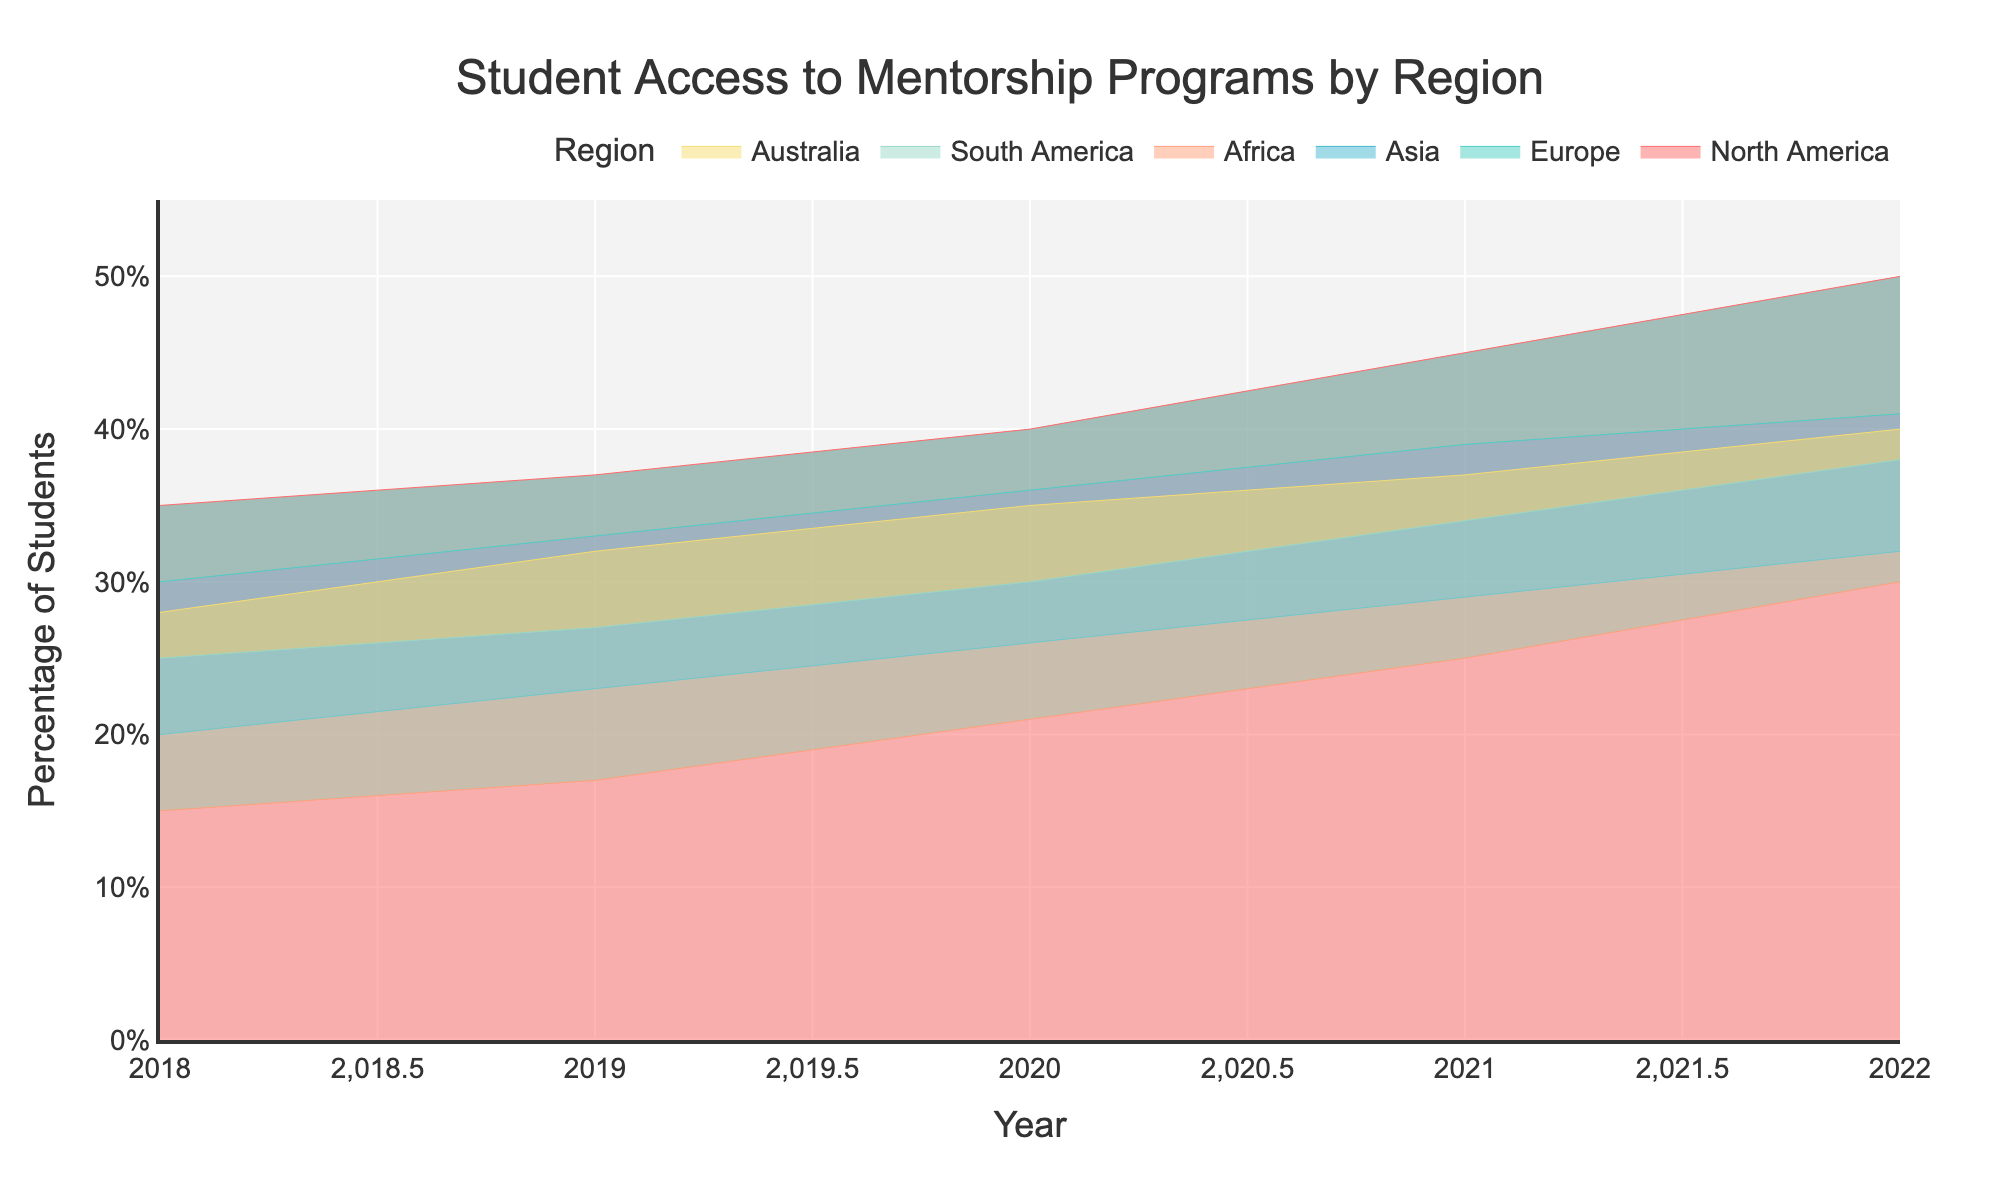How many regions are displayed in the chart? The title and legend of the chart help identify the number of regions displayed. Each color represents a different region.
Answer: 6 Between which years did North America see the highest increase in the percentage of students with access to mentorship programs? Reviewing the stepwise changes in percentage values for North America from year to year, the biggest jump is between 2020 and 2021 (5%).
Answer: 2020 to 2021 Which region had the lowest starting percentage in 2018? Observing the data at the start of the graph for each region, Africa starts with the lowest percentage (15%).
Answer: Africa What is the overall trend in student access to mentorship programs across all regions from 2018 to 2022? By observing the trends for all regions, there is a general increase in percentage, indicating improving access to mentorship programs over the years.
Answer: Increasing Comparing Europe and Asia, which region showed a higher increase in the percentage of students with access to mentorship programs from 2018 to 2022? For Europe: 41% - 30% = 11% increase. For Asia: 32% - 20% = 12% increase. Asia had a higher increase.
Answer: Asia By how much did the percentage of students with access to mentorship programs in South America change from 2019 to 2022? The initial percentage in 2019 is 27%, and in 2022 it is 38%. The difference is 38% - 27% = 11%.
Answer: 11% Combine the percentages of North America and Europe in the year 2022. What's the total percentage? Adding the percentages for North America (50%) and Europe (41%) in 2022 gives 50% + 41% = 91%.
Answer: 91% Which year had the most significant overall increase in access to mentorship programs, considering all regions? By comparing the year-to-year increases for each region, the year 2020 shows noticeable increments for most regions. This widespread increase indicates 2020 as the year with the most significant overall increase.
Answer: 2020 